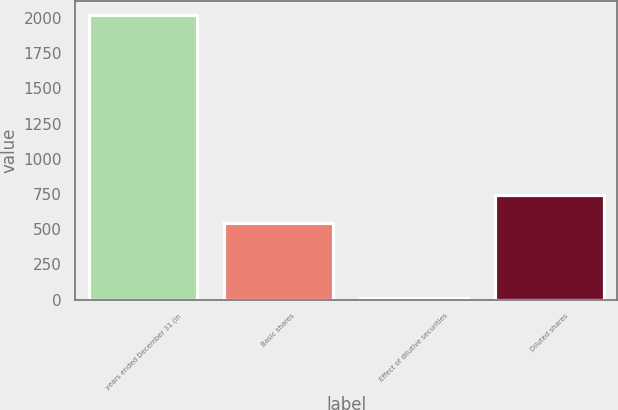Convert chart. <chart><loc_0><loc_0><loc_500><loc_500><bar_chart><fcel>years ended December 31 (in<fcel>Basic shares<fcel>Effect of dilutive securities<fcel>Diluted shares<nl><fcel>2017<fcel>543<fcel>12<fcel>743.5<nl></chart> 